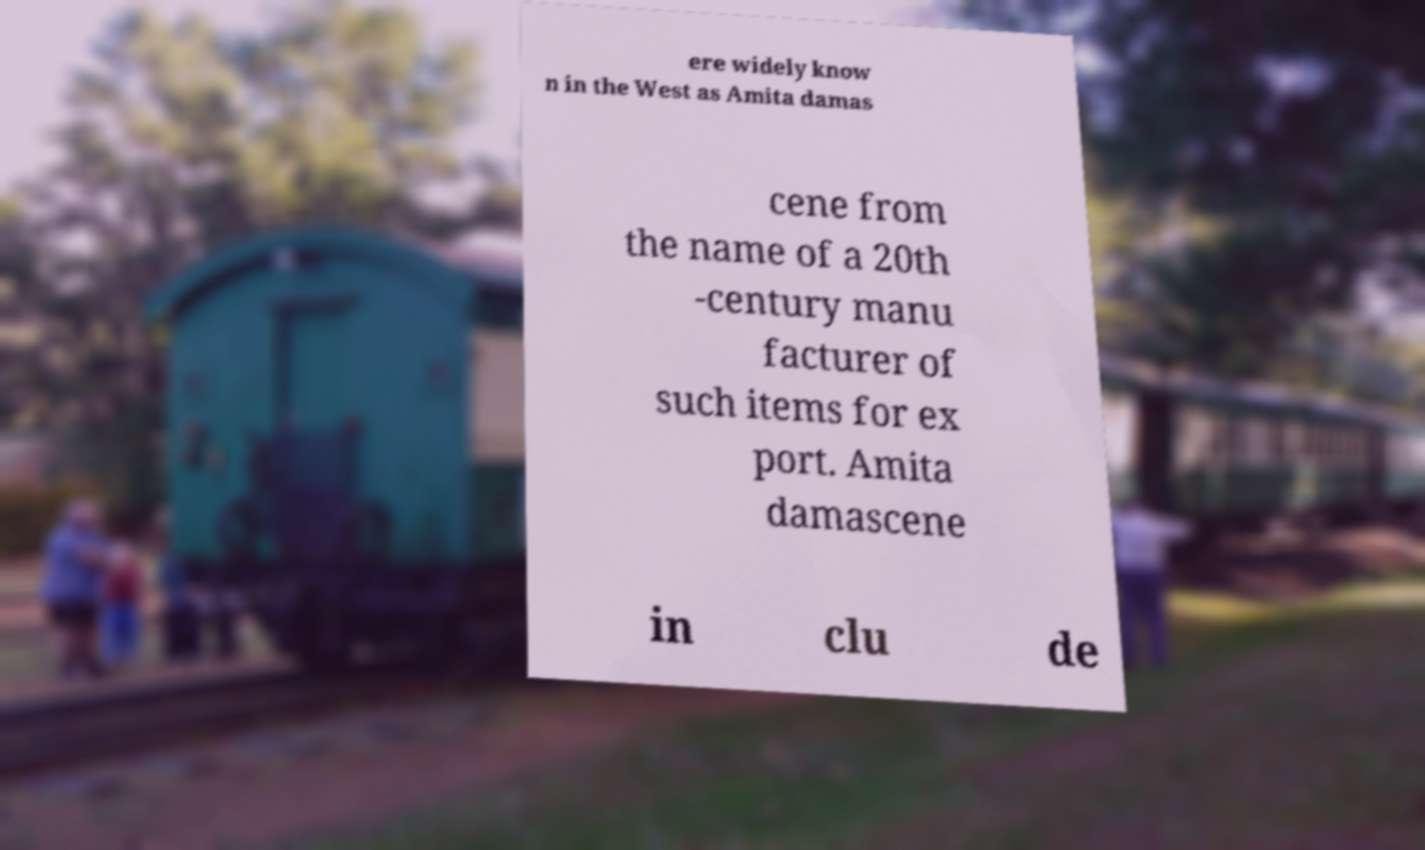Can you read and provide the text displayed in the image?This photo seems to have some interesting text. Can you extract and type it out for me? ere widely know n in the West as Amita damas cene from the name of a 20th -century manu facturer of such items for ex port. Amita damascene in clu de 